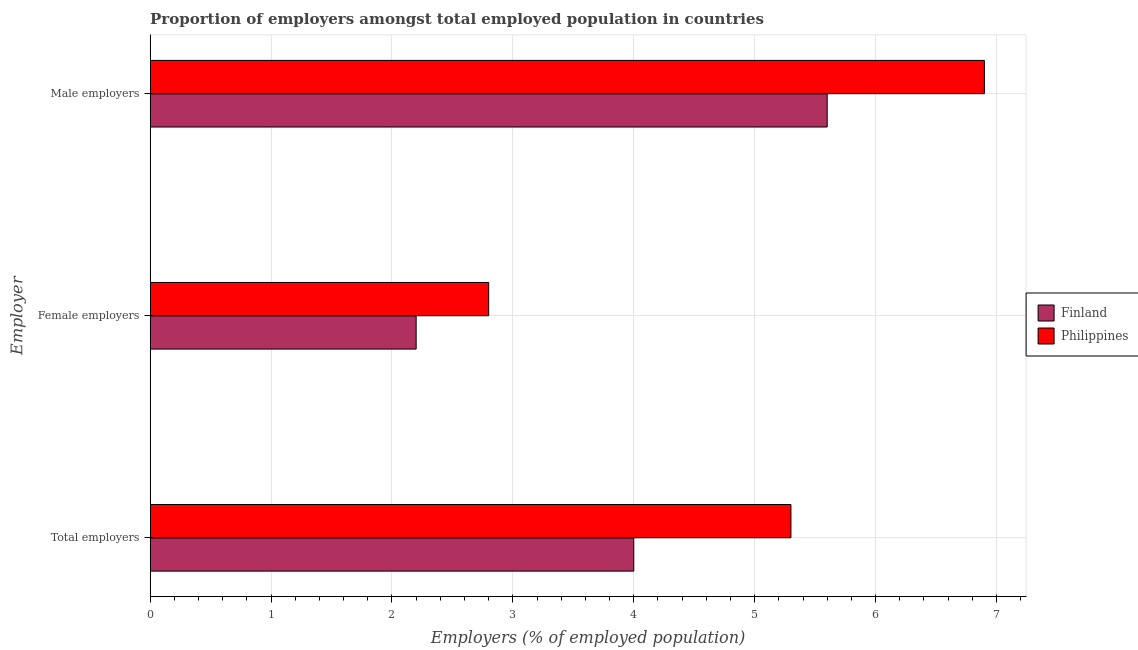Are the number of bars per tick equal to the number of legend labels?
Offer a very short reply. Yes. How many bars are there on the 2nd tick from the bottom?
Ensure brevity in your answer.  2. What is the label of the 3rd group of bars from the top?
Ensure brevity in your answer.  Total employers. What is the percentage of female employers in Philippines?
Provide a short and direct response. 2.8. Across all countries, what is the maximum percentage of total employers?
Provide a succinct answer. 5.3. Across all countries, what is the minimum percentage of female employers?
Your response must be concise. 2.2. In which country was the percentage of male employers maximum?
Give a very brief answer. Philippines. In which country was the percentage of male employers minimum?
Provide a short and direct response. Finland. What is the total percentage of total employers in the graph?
Your response must be concise. 9.3. What is the difference between the percentage of male employers in Philippines and that in Finland?
Your answer should be compact. 1.3. What is the difference between the percentage of female employers in Philippines and the percentage of male employers in Finland?
Offer a terse response. -2.8. What is the average percentage of total employers per country?
Keep it short and to the point. 4.65. What is the difference between the percentage of female employers and percentage of male employers in Philippines?
Your answer should be very brief. -4.1. In how many countries, is the percentage of male employers greater than 1 %?
Provide a succinct answer. 2. What is the ratio of the percentage of female employers in Finland to that in Philippines?
Offer a terse response. 0.79. Is the percentage of female employers in Philippines less than that in Finland?
Your response must be concise. No. Is the difference between the percentage of male employers in Finland and Philippines greater than the difference between the percentage of female employers in Finland and Philippines?
Give a very brief answer. No. What is the difference between the highest and the second highest percentage of male employers?
Your answer should be very brief. 1.3. What is the difference between the highest and the lowest percentage of female employers?
Offer a terse response. 0.6. Is the sum of the percentage of male employers in Philippines and Finland greater than the maximum percentage of total employers across all countries?
Your answer should be very brief. Yes. Is it the case that in every country, the sum of the percentage of total employers and percentage of female employers is greater than the percentage of male employers?
Ensure brevity in your answer.  Yes. How many bars are there?
Your answer should be compact. 6. How many countries are there in the graph?
Your answer should be very brief. 2. What is the difference between two consecutive major ticks on the X-axis?
Your answer should be very brief. 1. Are the values on the major ticks of X-axis written in scientific E-notation?
Offer a very short reply. No. Does the graph contain grids?
Give a very brief answer. Yes. How are the legend labels stacked?
Ensure brevity in your answer.  Vertical. What is the title of the graph?
Your answer should be compact. Proportion of employers amongst total employed population in countries. What is the label or title of the X-axis?
Give a very brief answer. Employers (% of employed population). What is the label or title of the Y-axis?
Ensure brevity in your answer.  Employer. What is the Employers (% of employed population) of Philippines in Total employers?
Provide a short and direct response. 5.3. What is the Employers (% of employed population) in Finland in Female employers?
Your answer should be compact. 2.2. What is the Employers (% of employed population) in Philippines in Female employers?
Make the answer very short. 2.8. What is the Employers (% of employed population) in Finland in Male employers?
Offer a very short reply. 5.6. What is the Employers (% of employed population) in Philippines in Male employers?
Your answer should be very brief. 6.9. Across all Employer, what is the maximum Employers (% of employed population) of Finland?
Keep it short and to the point. 5.6. Across all Employer, what is the maximum Employers (% of employed population) in Philippines?
Give a very brief answer. 6.9. Across all Employer, what is the minimum Employers (% of employed population) in Finland?
Your answer should be compact. 2.2. Across all Employer, what is the minimum Employers (% of employed population) of Philippines?
Make the answer very short. 2.8. What is the total Employers (% of employed population) in Philippines in the graph?
Your response must be concise. 15. What is the difference between the Employers (% of employed population) of Finland in Total employers and that in Male employers?
Your response must be concise. -1.6. What is the difference between the Employers (% of employed population) in Philippines in Female employers and that in Male employers?
Make the answer very short. -4.1. What is the difference between the Employers (% of employed population) of Finland in Total employers and the Employers (% of employed population) of Philippines in Female employers?
Your answer should be very brief. 1.2. What is the difference between the Employers (% of employed population) in Finland in Total employers and the Employers (% of employed population) in Philippines in Male employers?
Your response must be concise. -2.9. What is the difference between the Employers (% of employed population) in Finland in Female employers and the Employers (% of employed population) in Philippines in Male employers?
Keep it short and to the point. -4.7. What is the average Employers (% of employed population) of Finland per Employer?
Your response must be concise. 3.93. What is the difference between the Employers (% of employed population) in Finland and Employers (% of employed population) in Philippines in Female employers?
Provide a succinct answer. -0.6. What is the ratio of the Employers (% of employed population) of Finland in Total employers to that in Female employers?
Your answer should be very brief. 1.82. What is the ratio of the Employers (% of employed population) in Philippines in Total employers to that in Female employers?
Keep it short and to the point. 1.89. What is the ratio of the Employers (% of employed population) in Philippines in Total employers to that in Male employers?
Give a very brief answer. 0.77. What is the ratio of the Employers (% of employed population) in Finland in Female employers to that in Male employers?
Make the answer very short. 0.39. What is the ratio of the Employers (% of employed population) in Philippines in Female employers to that in Male employers?
Offer a very short reply. 0.41. What is the difference between the highest and the second highest Employers (% of employed population) in Finland?
Give a very brief answer. 1.6. What is the difference between the highest and the second highest Employers (% of employed population) of Philippines?
Make the answer very short. 1.6. What is the difference between the highest and the lowest Employers (% of employed population) of Finland?
Keep it short and to the point. 3.4. 